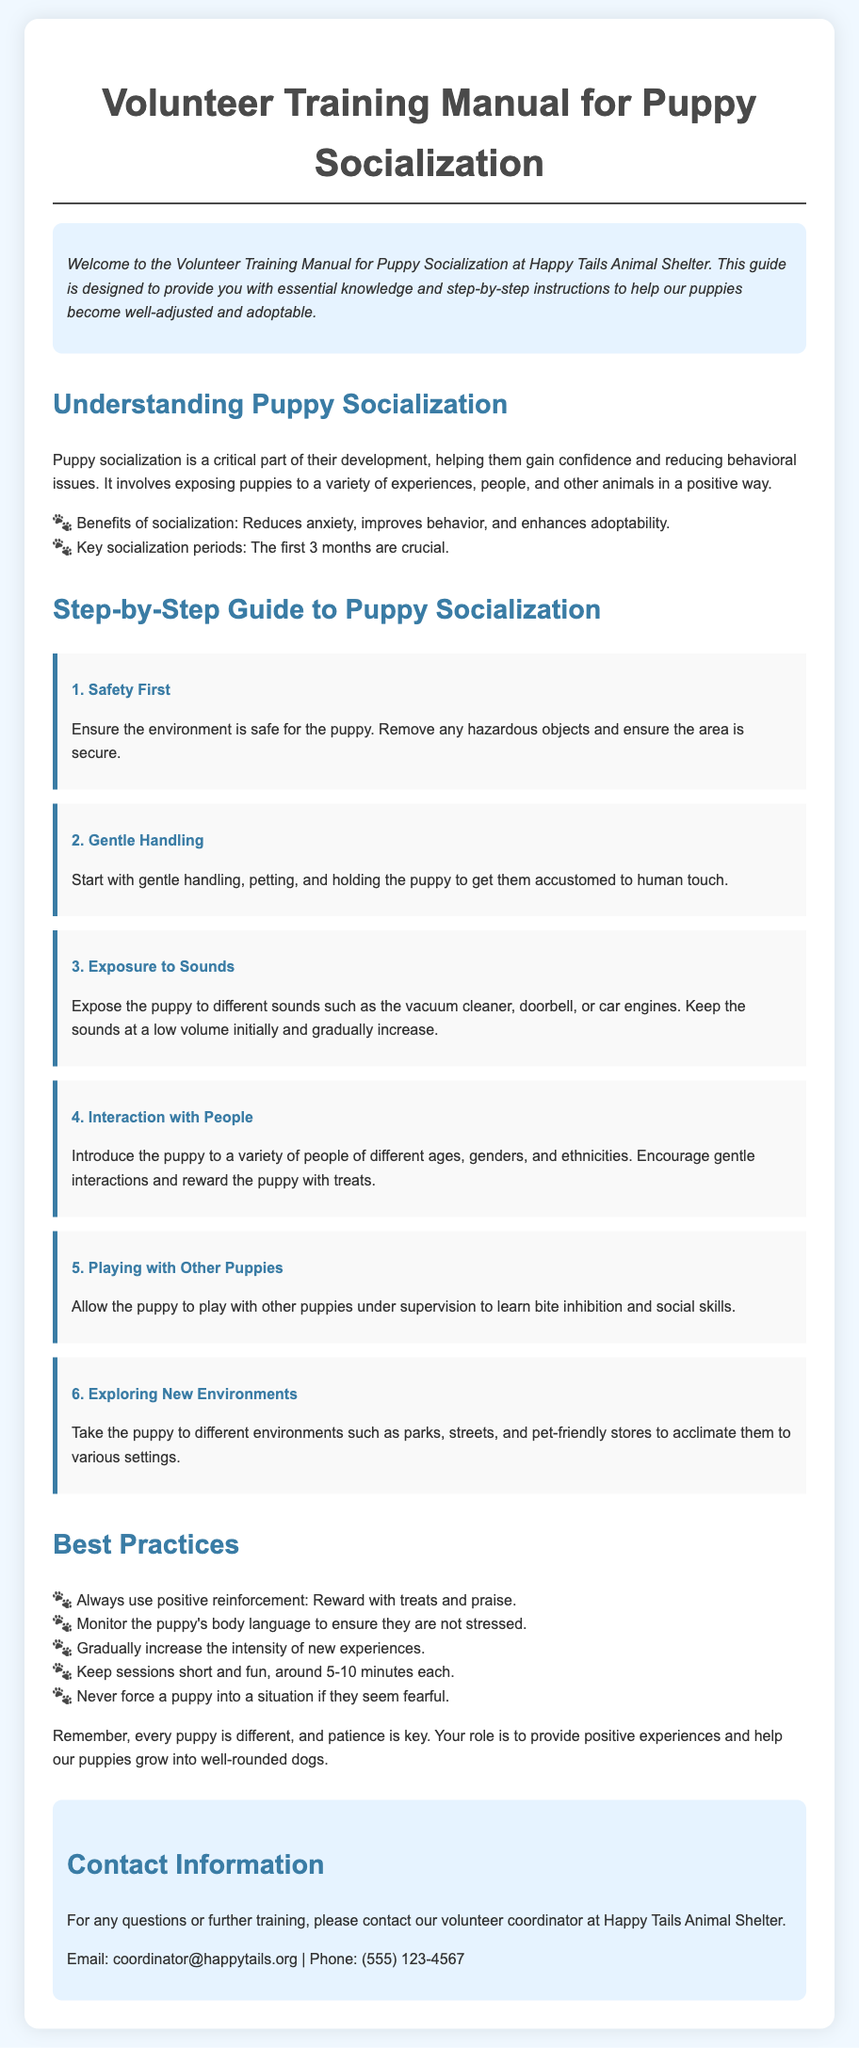What is the title of the document? The title of the document is presented prominently as the main heading at the top of the page.
Answer: Volunteer Training Manual for Puppy Socialization What are the benefits of puppy socialization? The document lists specific benefits of puppy socialization in a bulleted format.
Answer: Reduces anxiety, improves behavior, and enhances adoptability How many steps are in the step-by-step guide? The number of steps is indicated by the individual step headings in the guide section.
Answer: 6 What is the first step in the socialization process? The first step is mentioned with its title in the step-by-step guide.
Answer: Safety First What is a recommended duration for puppy socialization sessions? The document provides a guideline for how long each session should be.
Answer: 5-10 minutes What should you monitor during puppy socialization? The document advises an important aspect to keep track of during the process.
Answer: Puppy’s body language What type of reinforcement is emphasized in best practices? The document specifies the type of reinforcement that should always be used.
Answer: Positive reinforcement Who should be contacted for further training questions? Contact information for further assistance is provided at the end of the document.
Answer: Volunteer coordinator at Happy Tails Animal Shelter 